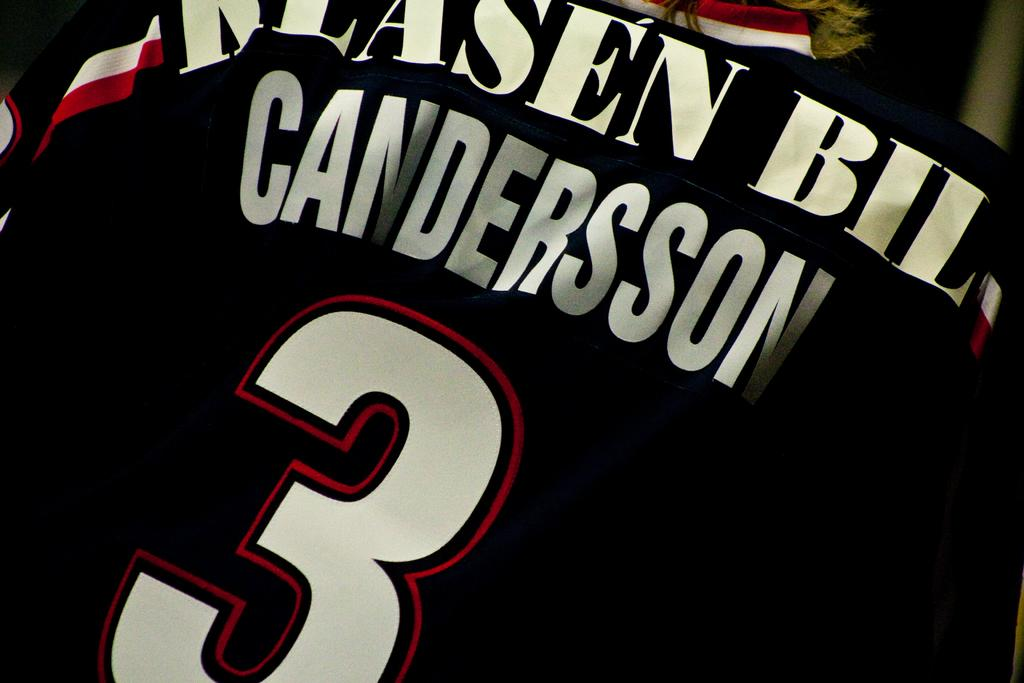<image>
Summarize the visual content of the image. A black sports jersey with the number 3 and the name Candersson written on it. 